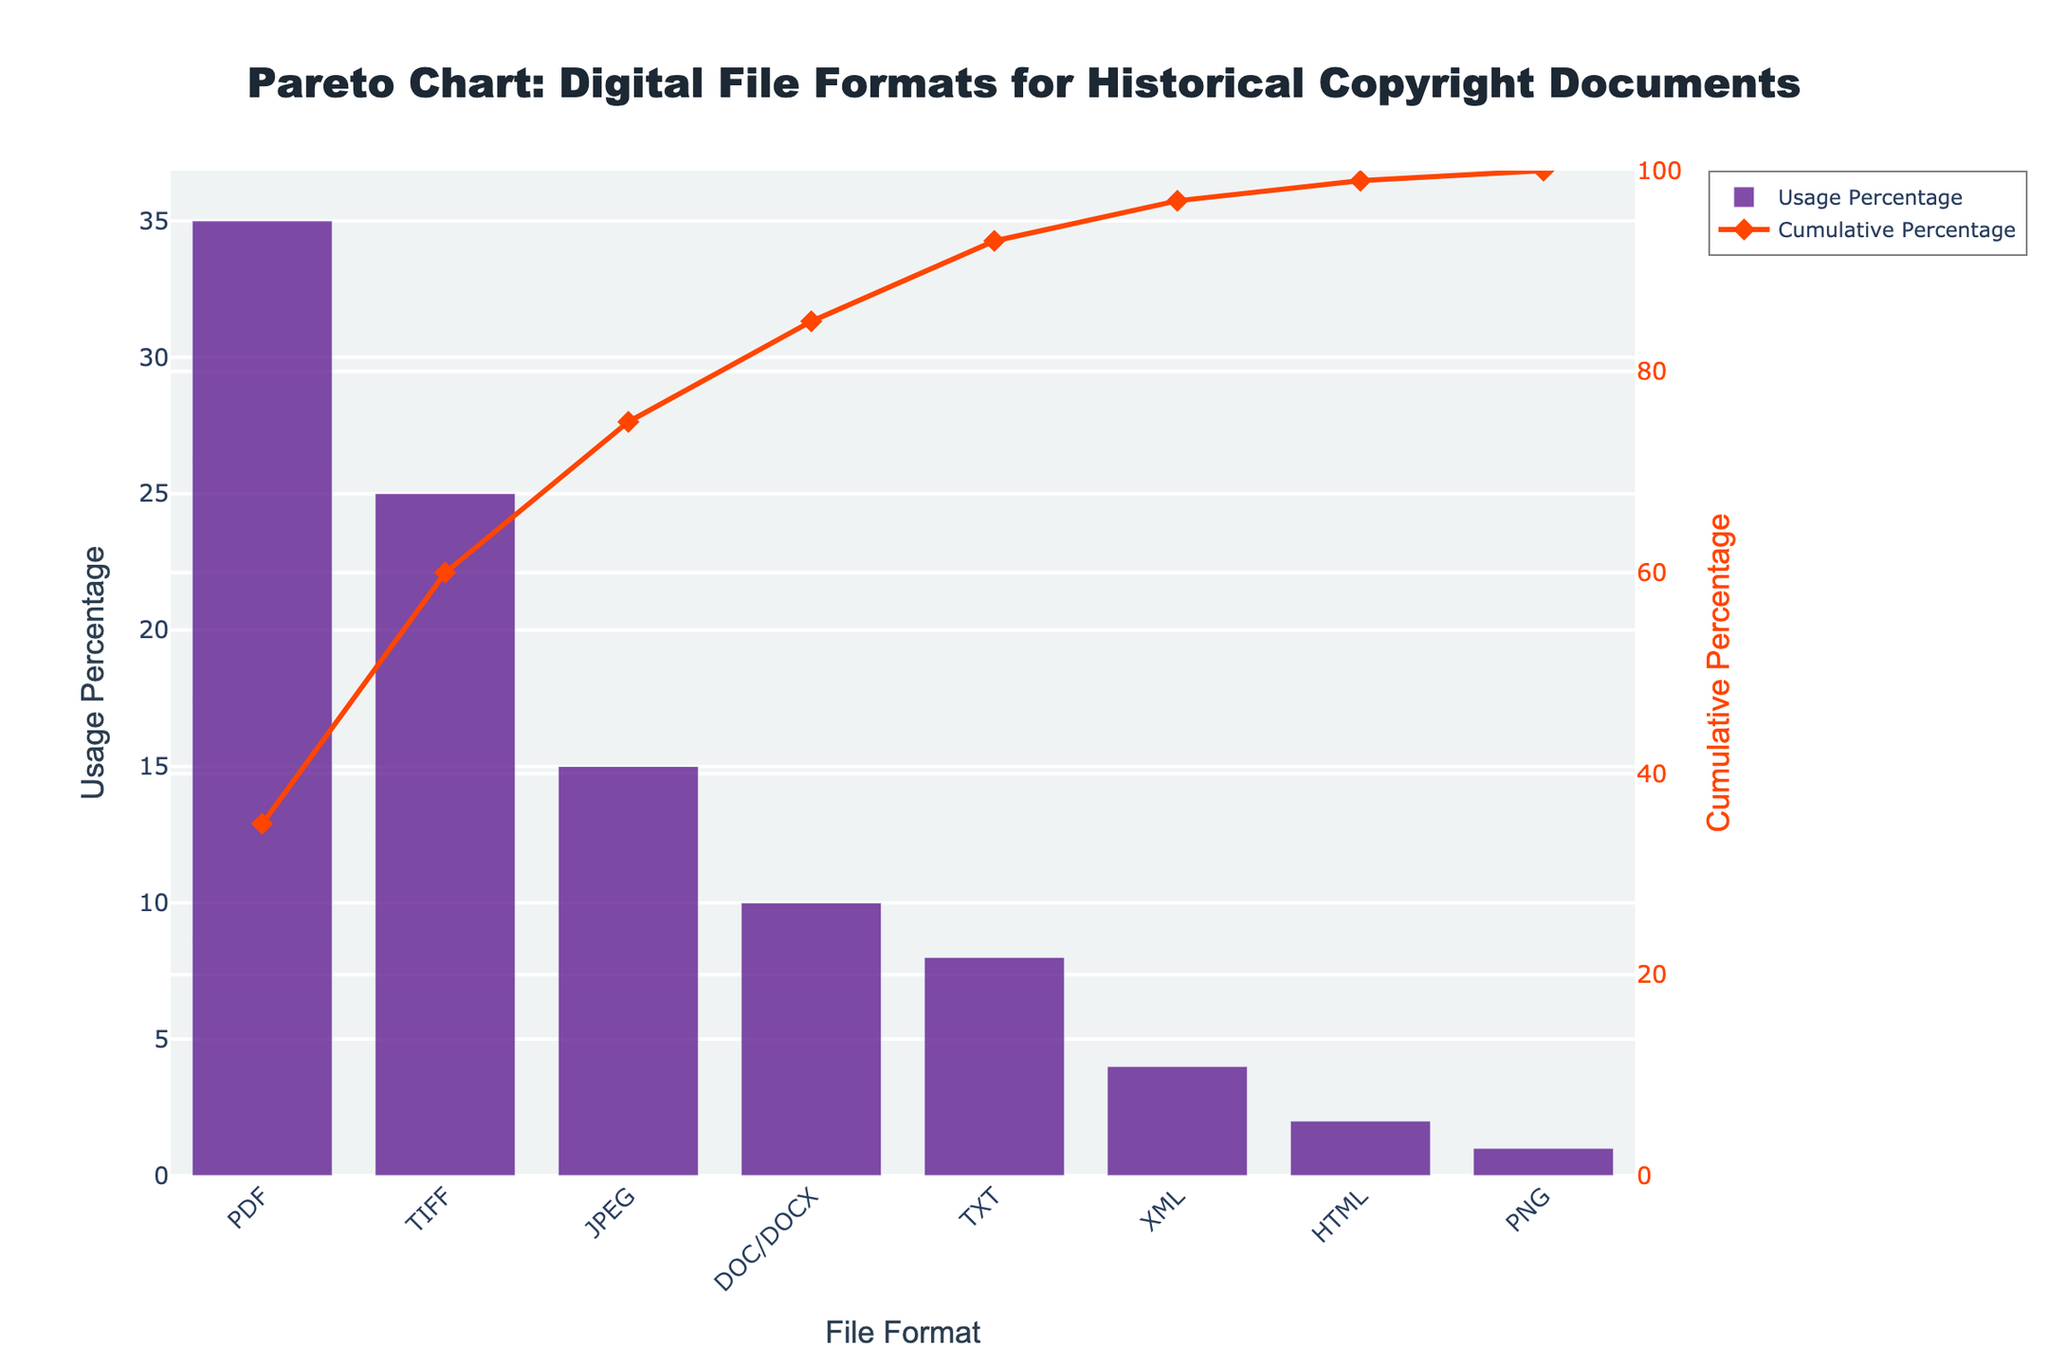What's the title of the figure? The title of the figure is at the top and provides a summary of what the figure is about. It reads: "Pareto Chart: Digital File Formats for Historical Copyright Documents."
Answer: Pareto Chart: Digital File Formats for Historical Copyright Documents Which file format has the highest usage percentage? The bar chart shows the usage percentage for each file format. The highest bar represents the file format with the highest usage percentage, which is PDF at 35%.
Answer: PDF What is the cumulative usage percentage up to TIFF? The cumulative percentage is shown by the line graph. By observing the data points, the cumulative percentage up to TIFF (after PDF) is 35% + 25% = 60%.
Answer: 60% How many file formats have a usage percentage higher than 10%? By examining the heights of the bars, we can see that PDF, TIFF, and JPEG each have usage percentages higher than 10%. Thus, there are three file formats.
Answer: 3 What is the total usage percentage of JPEG and DOC/DOCX combined? Add the usage percentages of JPEG and DOC/DOCX. JPEG = 15%, DOC/DOCX = 10%, so the total is 15% + 10% = 25%.
Answer: 25% Which file format contributes the least to the cumulative usage percentage? The file format with the smallest bar represents the least usage percentage, which is PNG at 1%.
Answer: PNG By observing the cumulative percentage, which file formats together surpass 80% usage? Cumulative percentage chart indicates that PDF, TIFF, JPEG, DOC/DOCX, and TXT together exceed 80%. For these formats, the cumulative percentages are 35%, 25%, 15%, 10%, and 8%, respectively. Adding them up: 35% + 25% + 15% + 10% + 8% = 93%.
Answer: PDF, TIFF, JPEG, DOC/DOCX, TXT What is the difference in usage percentage between the most common and least common file formats? The most common file format is PDF (35%) and the least common is PNG (1%). The difference between them is 35% - 1% = 34%.
Answer: 34% Among TXT, XML, and HTML, which one has the highest usage percentage? Comparing the bars for TXT, XML, and HTML, TXT has the highest usage percentage at 8%.
Answer: TXT 